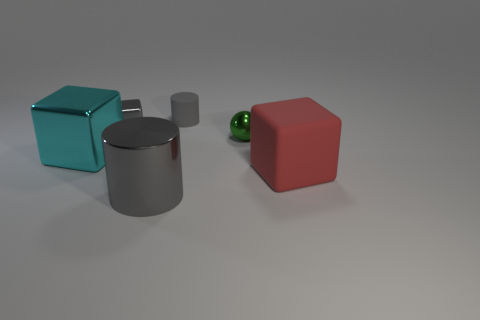Subtract all metallic blocks. How many blocks are left? 1 Subtract all cyan cubes. How many cubes are left? 2 Subtract all cylinders. How many objects are left? 4 Subtract 1 balls. How many balls are left? 0 Subtract 0 blue cylinders. How many objects are left? 6 Subtract all green blocks. Subtract all brown cylinders. How many blocks are left? 3 Subtract all yellow cylinders. How many red blocks are left? 1 Subtract all tiny green rubber cubes. Subtract all large blocks. How many objects are left? 4 Add 2 shiny cylinders. How many shiny cylinders are left? 3 Add 6 big green rubber objects. How many big green rubber objects exist? 6 